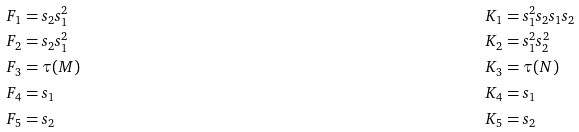Convert formula to latex. <formula><loc_0><loc_0><loc_500><loc_500>F _ { 1 } & = s _ { 2 } s _ { 1 } ^ { 2 } & K _ { 1 } & = s _ { 1 } ^ { 2 } s _ { 2 } s _ { 1 } s _ { 2 } \\ F _ { 2 } & = s _ { 2 } s _ { 1 } ^ { 2 } & K _ { 2 } & = s _ { 1 } ^ { 2 } s _ { 2 } ^ { 2 } \\ F _ { 3 } & = \tau ( M ) & K _ { 3 } & = \tau ( N ) \\ F _ { 4 } & = s _ { 1 } & K _ { 4 } & = s _ { 1 } \\ F _ { 5 } & = s _ { 2 } & K _ { 5 } & = s _ { 2 }</formula> 